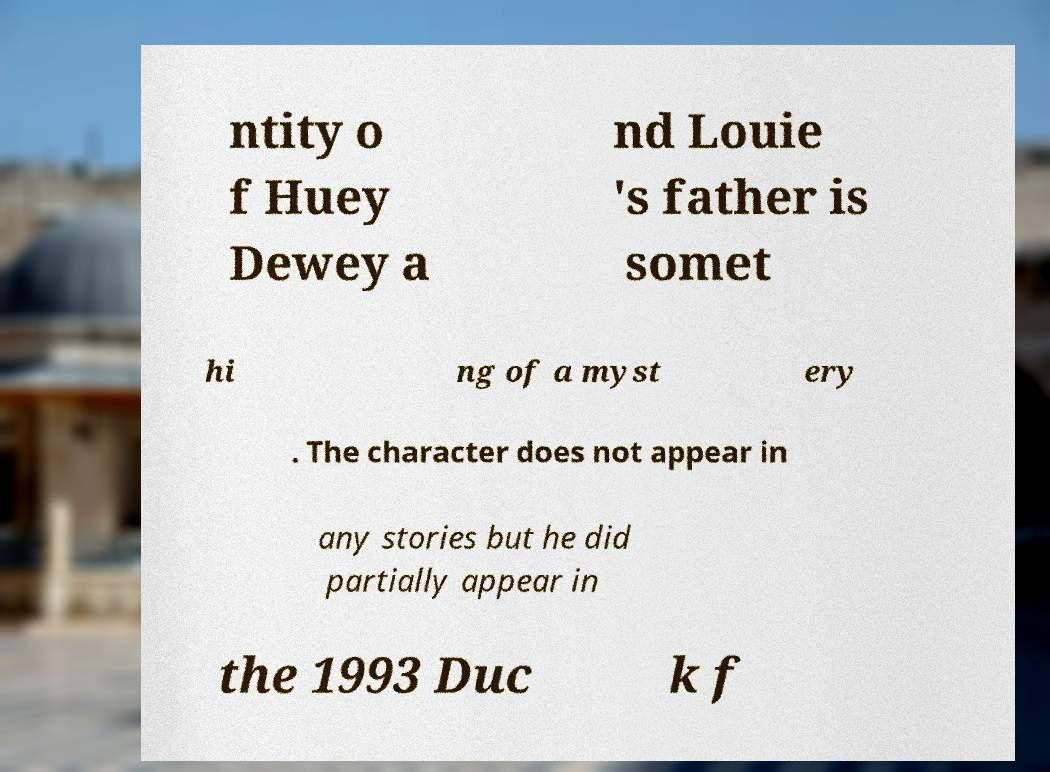Can you read and provide the text displayed in the image?This photo seems to have some interesting text. Can you extract and type it out for me? ntity o f Huey Dewey a nd Louie 's father is somet hi ng of a myst ery . The character does not appear in any stories but he did partially appear in the 1993 Duc k f 